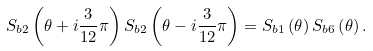<formula> <loc_0><loc_0><loc_500><loc_500>S _ { b 2 } \left ( \theta + i \frac { 3 } { 1 2 } \pi \right ) S _ { b 2 } \left ( \theta - i \frac { 3 } { 1 2 } \pi \right ) = S _ { b 1 } \left ( \theta \right ) S _ { b 6 } \left ( \theta \right ) .</formula> 